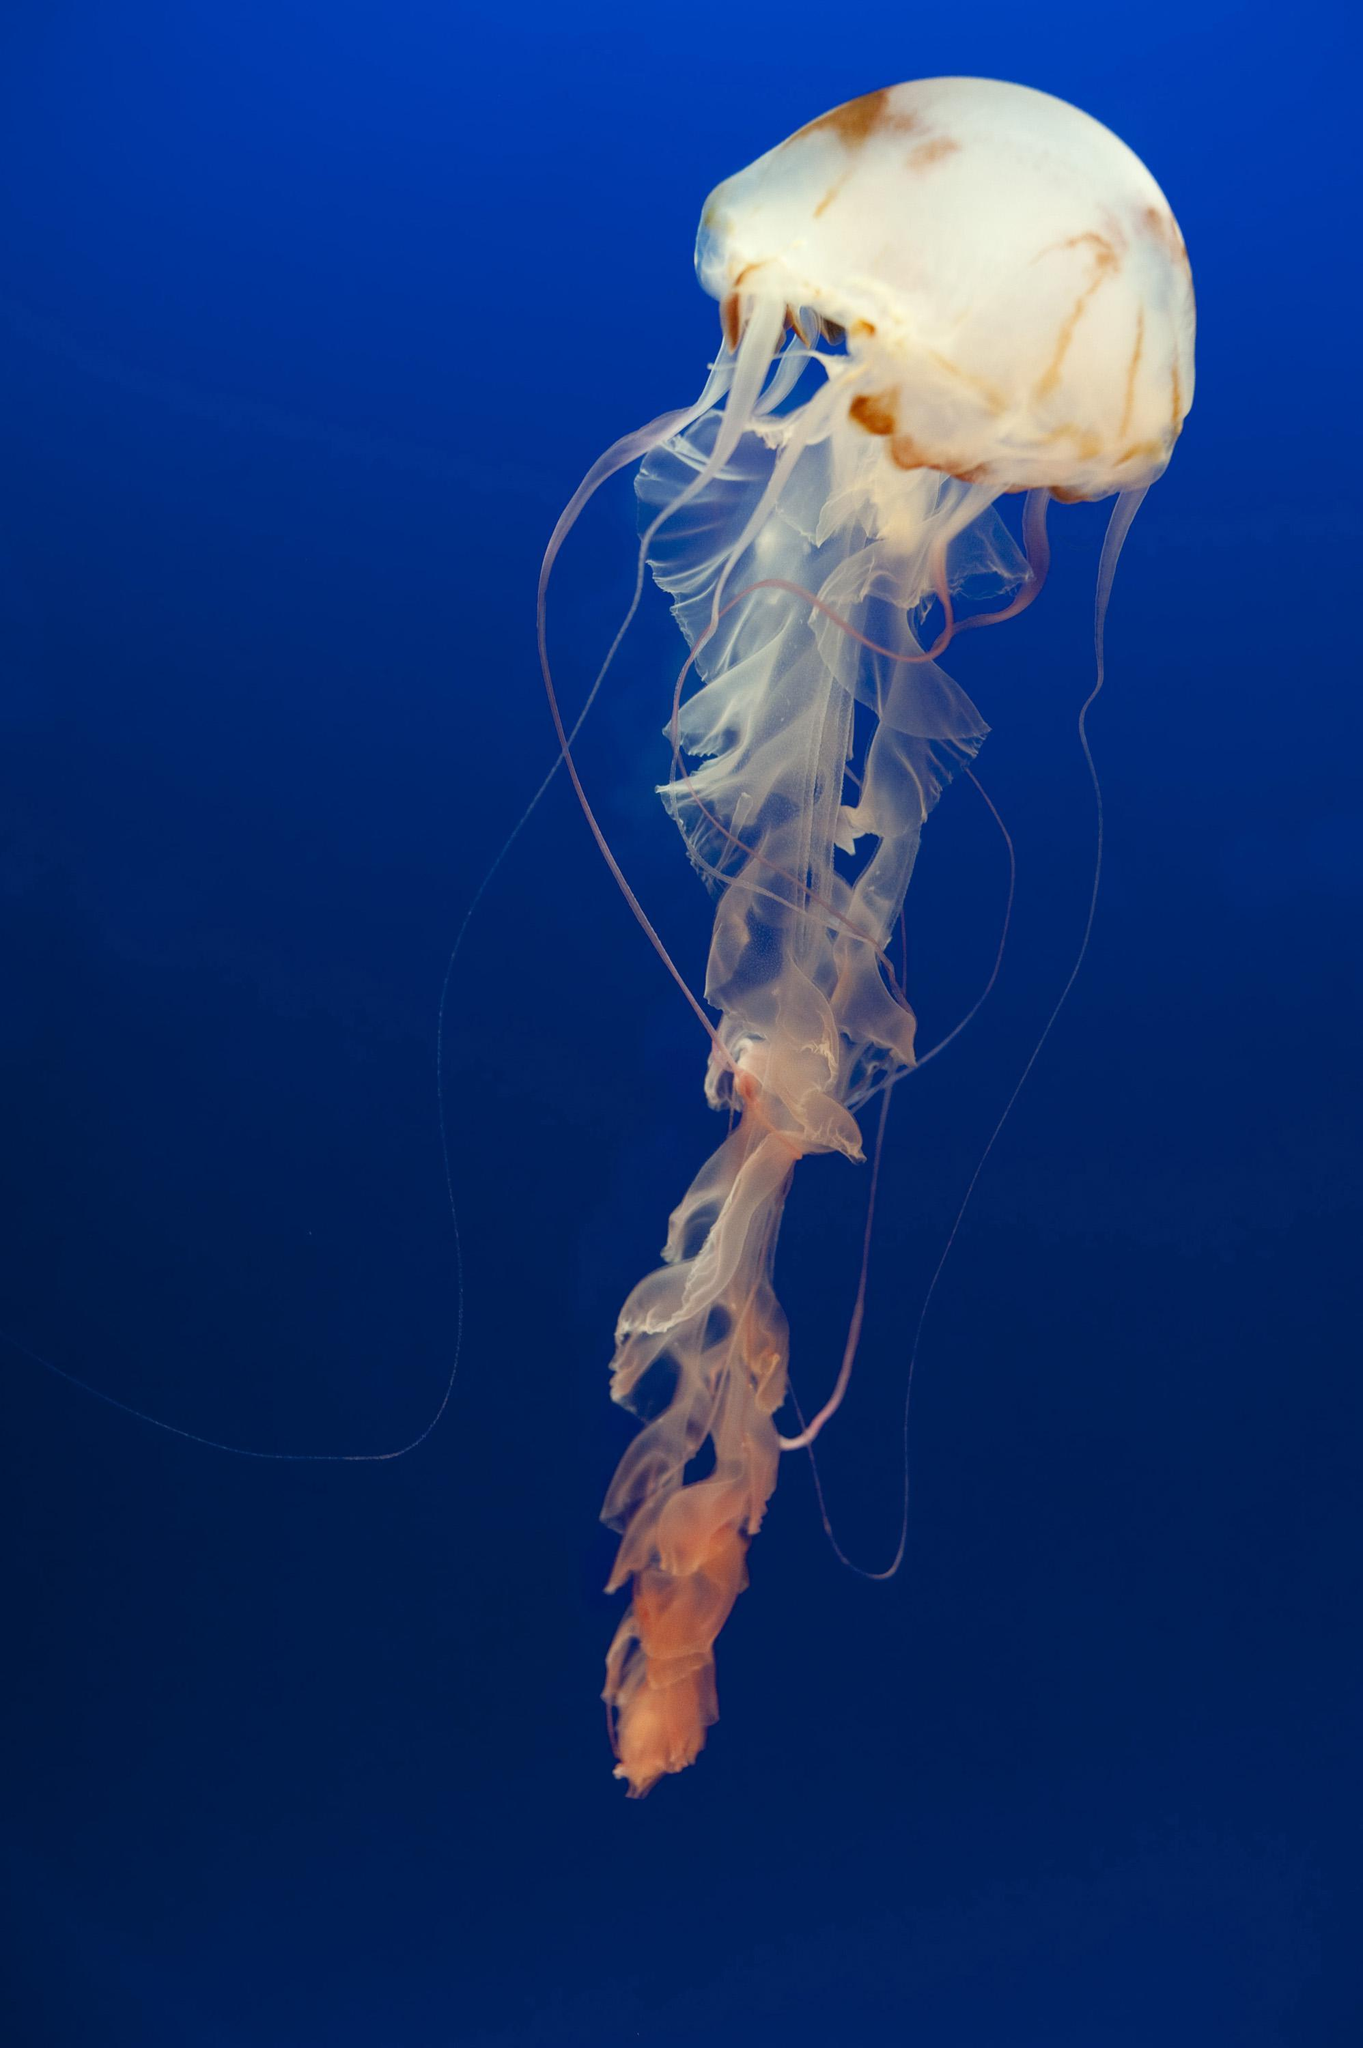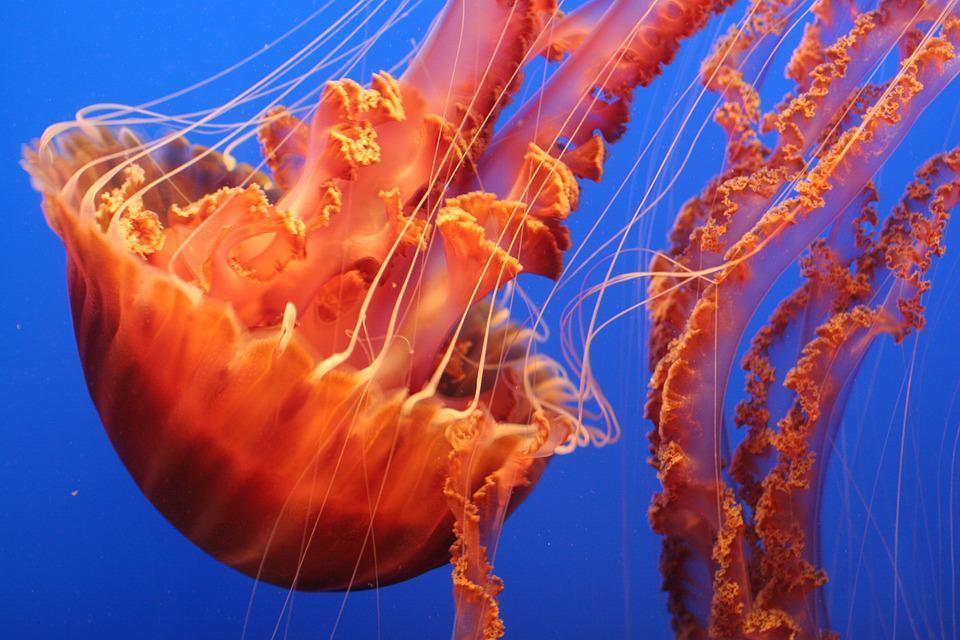The first image is the image on the left, the second image is the image on the right. For the images shown, is this caption "The right image shows at least one vivid orange jellyfish." true? Answer yes or no. Yes. 